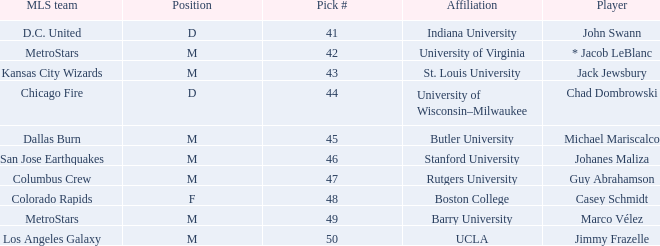What position has UCLA pick that is larger than #47? M. 